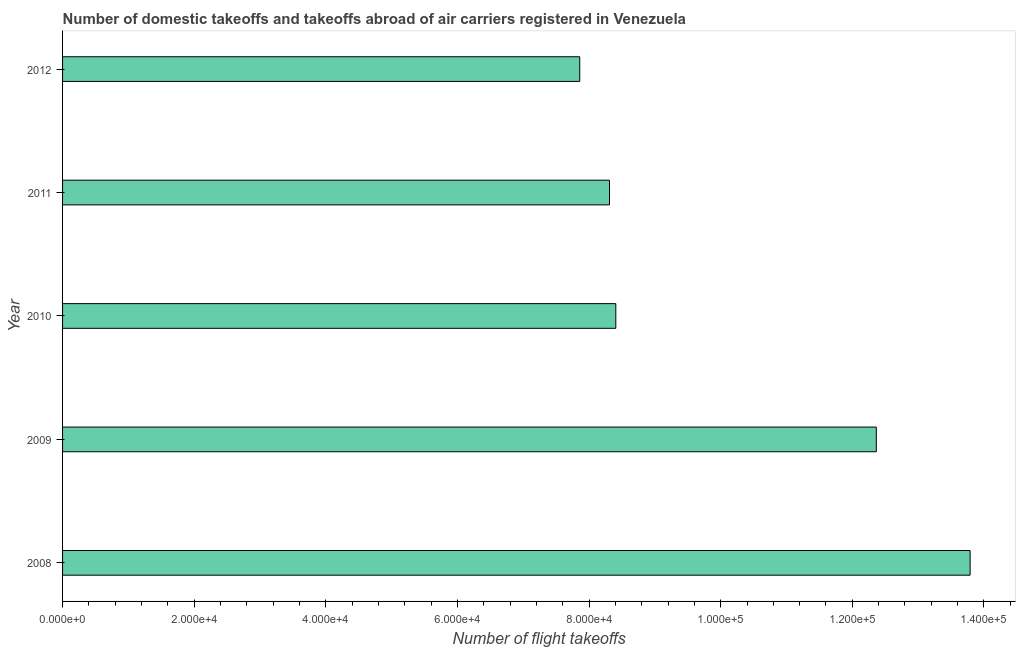Does the graph contain any zero values?
Keep it short and to the point. No. Does the graph contain grids?
Offer a very short reply. No. What is the title of the graph?
Provide a short and direct response. Number of domestic takeoffs and takeoffs abroad of air carriers registered in Venezuela. What is the label or title of the X-axis?
Your answer should be compact. Number of flight takeoffs. What is the number of flight takeoffs in 2012?
Provide a short and direct response. 7.86e+04. Across all years, what is the maximum number of flight takeoffs?
Provide a succinct answer. 1.38e+05. Across all years, what is the minimum number of flight takeoffs?
Make the answer very short. 7.86e+04. In which year was the number of flight takeoffs maximum?
Provide a short and direct response. 2008. What is the sum of the number of flight takeoffs?
Your answer should be very brief. 5.07e+05. What is the difference between the number of flight takeoffs in 2010 and 2012?
Your response must be concise. 5481.84. What is the average number of flight takeoffs per year?
Your answer should be very brief. 1.01e+05. What is the median number of flight takeoffs?
Give a very brief answer. 8.41e+04. In how many years, is the number of flight takeoffs greater than 88000 ?
Give a very brief answer. 2. Do a majority of the years between 2009 and 2011 (inclusive) have number of flight takeoffs greater than 20000 ?
Your answer should be compact. Yes. What is the ratio of the number of flight takeoffs in 2008 to that in 2010?
Provide a short and direct response. 1.64. Is the number of flight takeoffs in 2009 less than that in 2011?
Offer a very short reply. No. Is the difference between the number of flight takeoffs in 2008 and 2010 greater than the difference between any two years?
Give a very brief answer. No. What is the difference between the highest and the second highest number of flight takeoffs?
Your answer should be compact. 1.43e+04. Is the sum of the number of flight takeoffs in 2010 and 2011 greater than the maximum number of flight takeoffs across all years?
Provide a short and direct response. Yes. What is the difference between the highest and the lowest number of flight takeoffs?
Keep it short and to the point. 5.93e+04. How many bars are there?
Your answer should be compact. 5. Are all the bars in the graph horizontal?
Offer a very short reply. Yes. Are the values on the major ticks of X-axis written in scientific E-notation?
Ensure brevity in your answer.  Yes. What is the Number of flight takeoffs in 2008?
Provide a short and direct response. 1.38e+05. What is the Number of flight takeoffs in 2009?
Make the answer very short. 1.24e+05. What is the Number of flight takeoffs of 2010?
Provide a succinct answer. 8.41e+04. What is the Number of flight takeoffs in 2011?
Your response must be concise. 8.31e+04. What is the Number of flight takeoffs in 2012?
Offer a very short reply. 7.86e+04. What is the difference between the Number of flight takeoffs in 2008 and 2009?
Your response must be concise. 1.43e+04. What is the difference between the Number of flight takeoffs in 2008 and 2010?
Offer a terse response. 5.38e+04. What is the difference between the Number of flight takeoffs in 2008 and 2011?
Provide a short and direct response. 5.48e+04. What is the difference between the Number of flight takeoffs in 2008 and 2012?
Your response must be concise. 5.93e+04. What is the difference between the Number of flight takeoffs in 2009 and 2010?
Ensure brevity in your answer.  3.96e+04. What is the difference between the Number of flight takeoffs in 2009 and 2011?
Your answer should be very brief. 4.05e+04. What is the difference between the Number of flight takeoffs in 2009 and 2012?
Your answer should be very brief. 4.51e+04. What is the difference between the Number of flight takeoffs in 2010 and 2011?
Keep it short and to the point. 959. What is the difference between the Number of flight takeoffs in 2010 and 2012?
Your answer should be very brief. 5481.84. What is the difference between the Number of flight takeoffs in 2011 and 2012?
Provide a succinct answer. 4522.84. What is the ratio of the Number of flight takeoffs in 2008 to that in 2009?
Offer a terse response. 1.11. What is the ratio of the Number of flight takeoffs in 2008 to that in 2010?
Ensure brevity in your answer.  1.64. What is the ratio of the Number of flight takeoffs in 2008 to that in 2011?
Offer a very short reply. 1.66. What is the ratio of the Number of flight takeoffs in 2008 to that in 2012?
Provide a succinct answer. 1.75. What is the ratio of the Number of flight takeoffs in 2009 to that in 2010?
Keep it short and to the point. 1.47. What is the ratio of the Number of flight takeoffs in 2009 to that in 2011?
Keep it short and to the point. 1.49. What is the ratio of the Number of flight takeoffs in 2009 to that in 2012?
Provide a short and direct response. 1.57. What is the ratio of the Number of flight takeoffs in 2010 to that in 2012?
Provide a short and direct response. 1.07. What is the ratio of the Number of flight takeoffs in 2011 to that in 2012?
Your answer should be very brief. 1.06. 